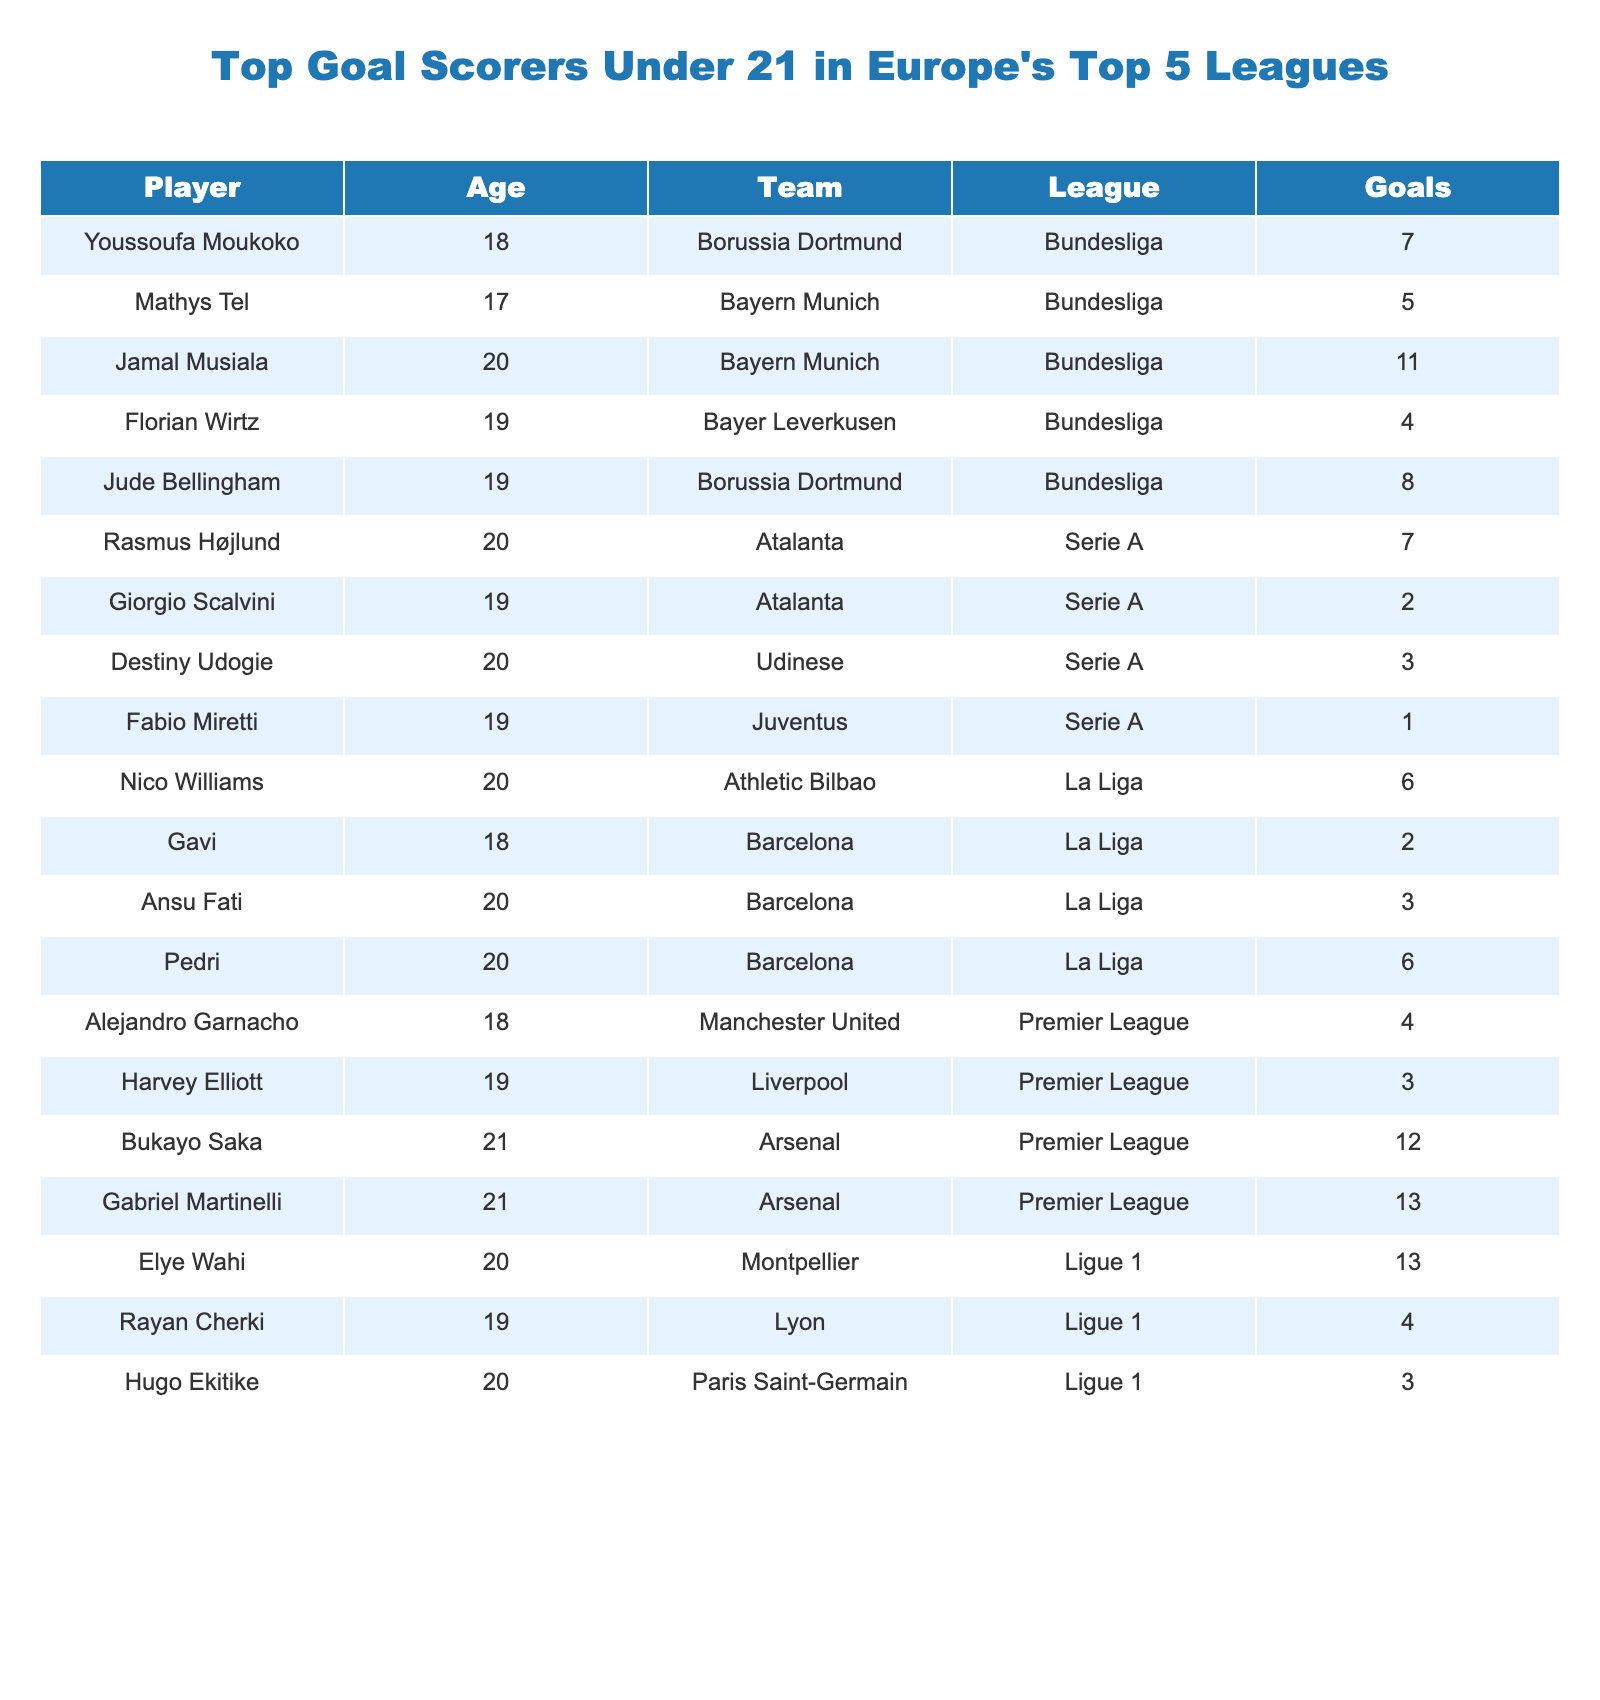What is the total number of goals scored by players from Bayern Munich? There are two players from Bayern Munich listed in the table: Jamal Musiala with 11 goals and Mathys Tel with 5 goals. Summing them gives 11 + 5 = 16.
Answer: 16 Who is the youngest player among the top goal scorers? Youssoufa Moukoko is listed as the youngest player at 18 years old. The other players listed who are 18 years old are Gavi and Alejandro Garnacho, but Moukoko has more goals than Wirtz, who is also 19.
Answer: Youssoufa Moukoko What is the total number of goals scored by all players aged 20 or older? The only players aged 20 or older who appear in this table are Bukayo Saka and Gabriel Martinelli (both 21). Their combined goals are 12 + 13 = 25.
Answer: 25 Which league has the most players listed among the top goal scorers under 21? By counting the players in each league, the Bundesliga has 5 players, Serie A has 4, La Liga has 4, Premier League has 3, and Ligue 1 has 3. Thus, Bundesliga has the most players listed.
Answer: Bundesliga Is there any player who has scored more than 10 goals? The table indicates that there are two players with more than 10 goals: Jamal Musiala with 11 and Gabriel Martinelli with 13.
Answer: Yes Which player has scored the least number of goals? Fabio Miretti has the least number of goals with just 1.
Answer: Fabio Miretti What is the average number of goals scored by players from Atalanta? The players from Atalanta are Rasmus Højlund with 7 goals and Giorgio Scalvini with 2 goals. The average is calculated as (7 + 2) / 2 = 4.5.
Answer: 4.5 How many players scored exactly 4 goals? There are three players with exactly 4 goals: Florian Wirtz, Rayan Cherki, and Alejandro Garnacho.
Answer: 3 Who scored more goals: players from La Liga or players from Ligue 1? In La Liga, the total goals are 2 + 3 + 6 + 4 = 15, and in Ligue 1, they're 4 + 3 + 13 = 20. Comparing these totals, Ligue 1 has more goals.
Answer: Ligue 1 What is the difference in total goals between the top scorer and the lowest scorer in this table? The top scorer is Gabriel Martinelli with 13 goals, and the lowest is Fabio Miretti with 1 goal. Therefore, the difference is 13 - 1 = 12.
Answer: 12 